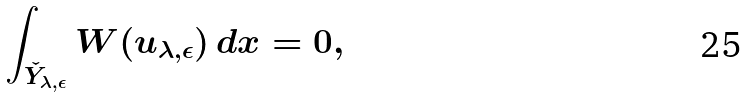<formula> <loc_0><loc_0><loc_500><loc_500>\int _ { \check { Y } _ { \lambda , \epsilon } } { W ( u _ { \lambda , \epsilon } ) \, d x } = 0 ,</formula> 